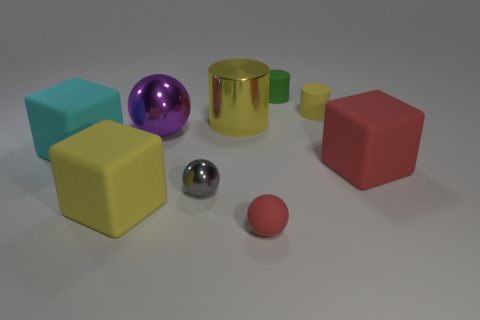Add 1 yellow things. How many objects exist? 10 Subtract all cubes. How many objects are left? 6 Subtract all red spheres. Subtract all yellow rubber cubes. How many objects are left? 7 Add 2 yellow metal things. How many yellow metal things are left? 3 Add 4 small yellow matte spheres. How many small yellow matte spheres exist? 4 Subtract 1 gray spheres. How many objects are left? 8 